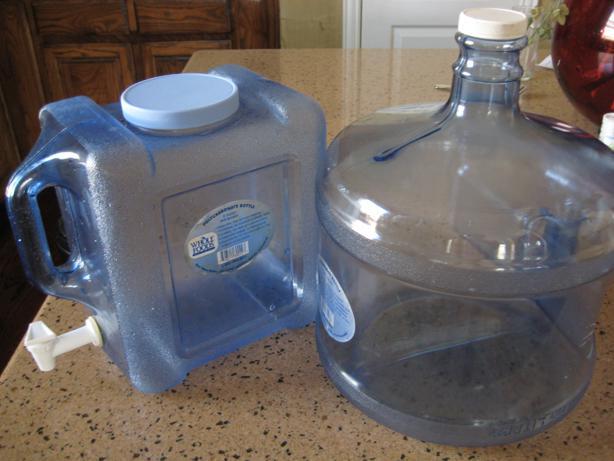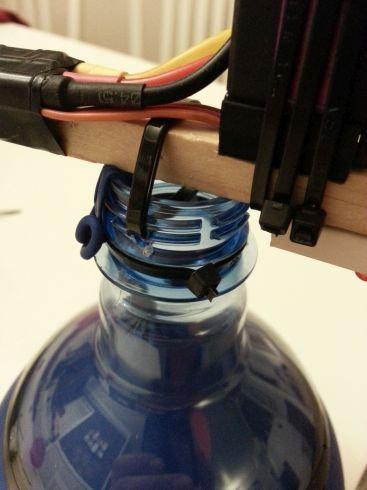The first image is the image on the left, the second image is the image on the right. For the images displayed, is the sentence "An image shows at least one water jug stacked inverted on upright jugs." factually correct? Answer yes or no. No. The first image is the image on the left, the second image is the image on the right. Given the left and right images, does the statement "There are more than three water containers standing up." hold true? Answer yes or no. No. 